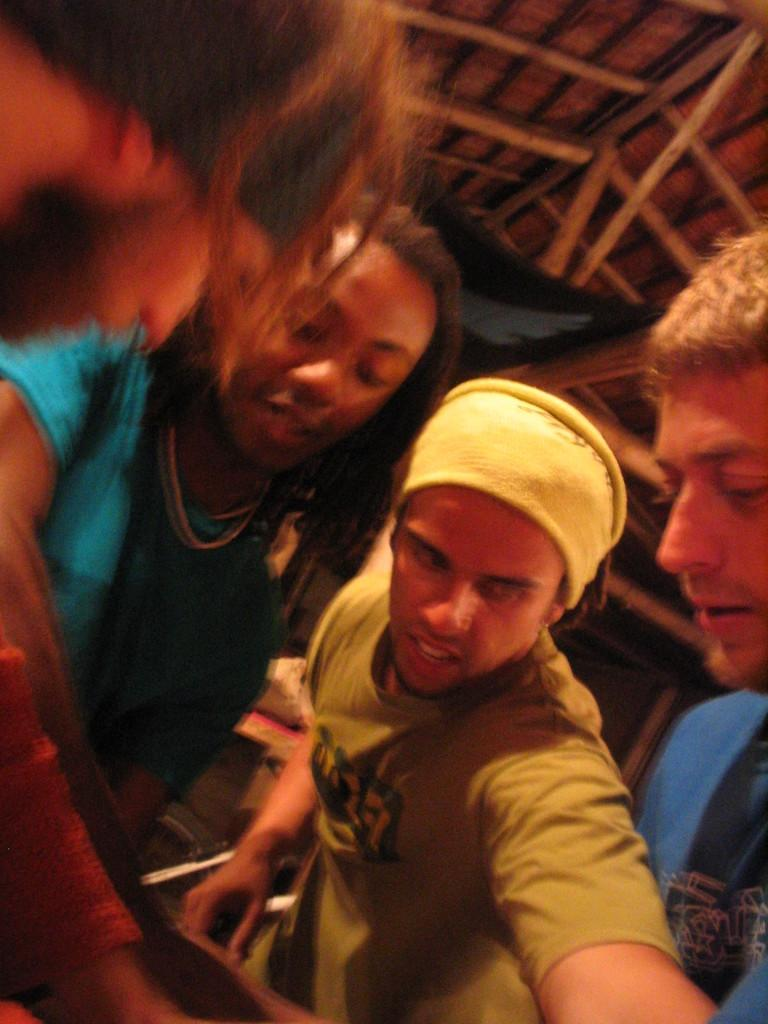How many people are in the image? There are four members in the image. What is the gender of the people in the image? All the members are men. Can you describe any specific clothing or accessories worn by one of the men? One of the men is wearing a cap on his head. What type of ceiling can be seen in the background of the image? There is a wooden ceiling in the background of the image. How does the hose help the men in the image? There is no hose present in the image, so it cannot help the men in any way. 